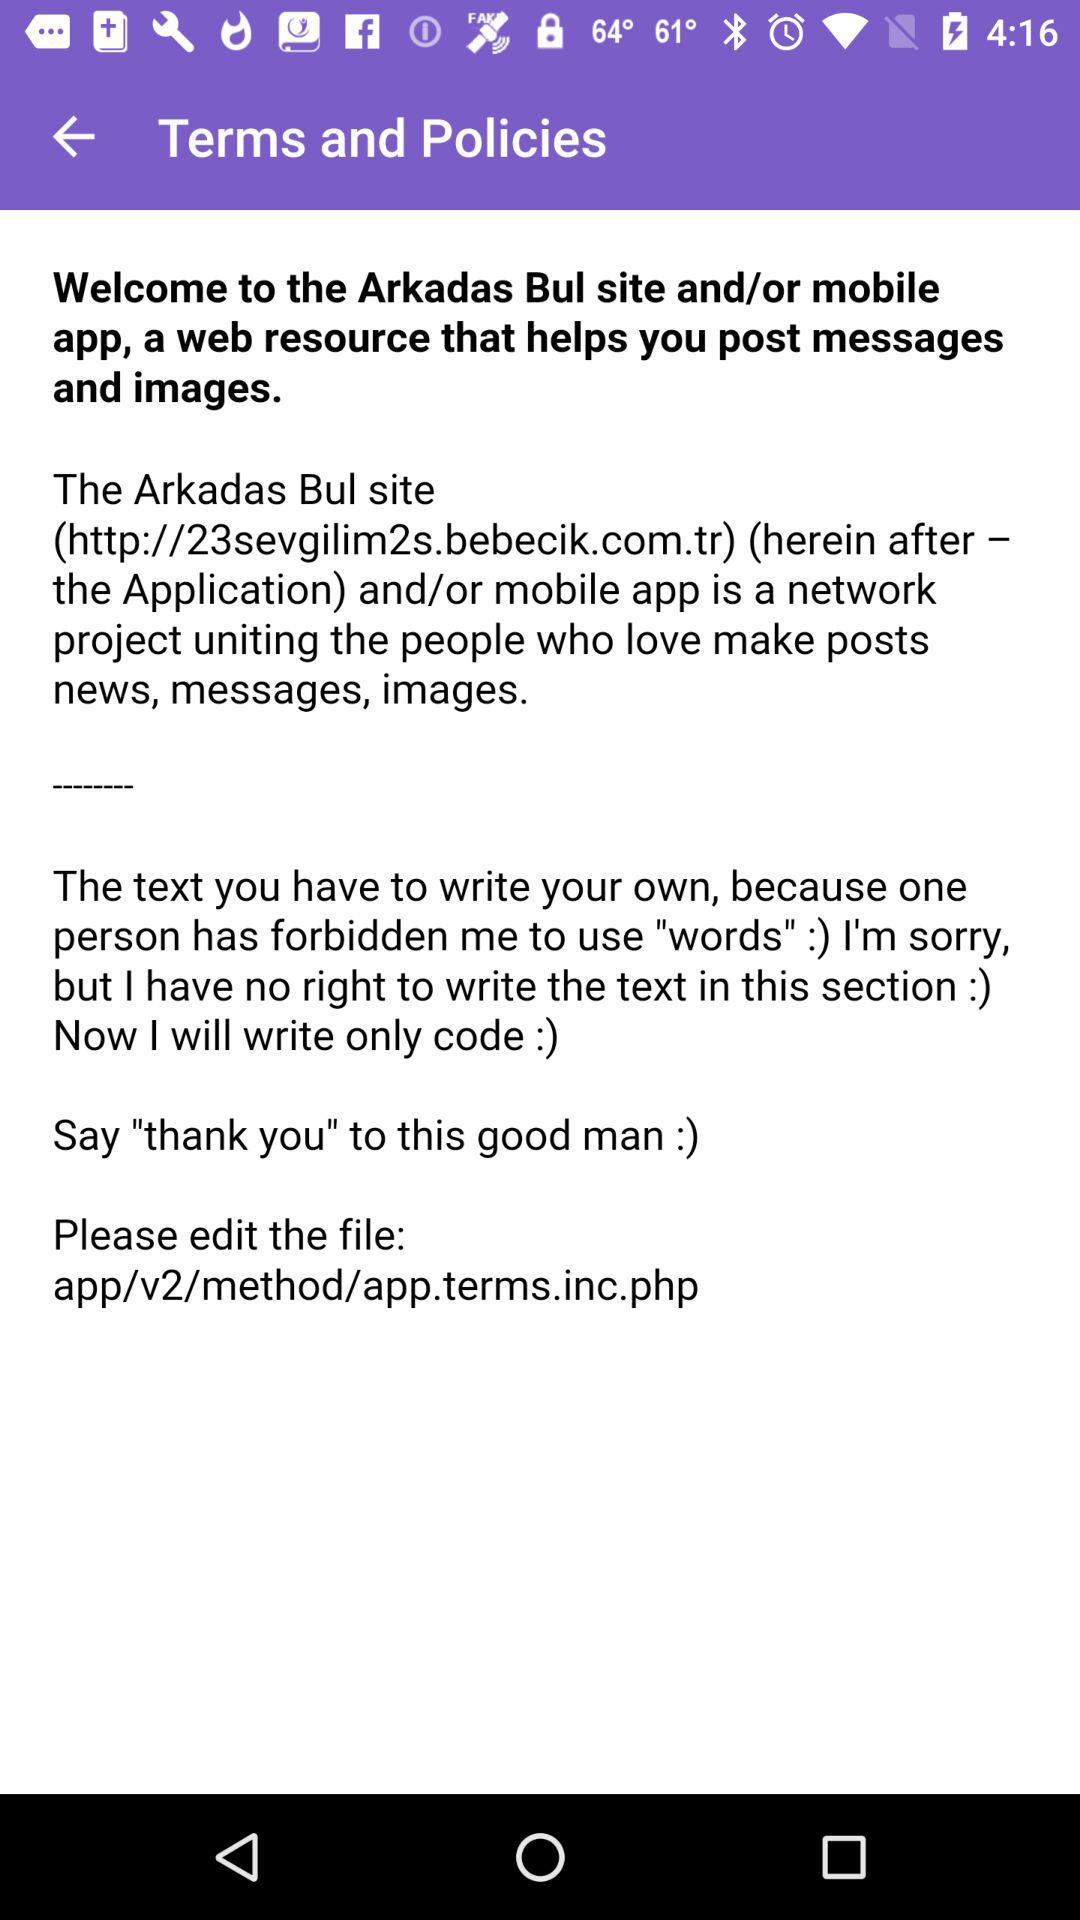What's the file link? The file link is app/v2/method/app.terms.inc.php. 